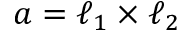<formula> <loc_0><loc_0><loc_500><loc_500>a = \ell _ { 1 } \times \ell _ { 2 }</formula> 